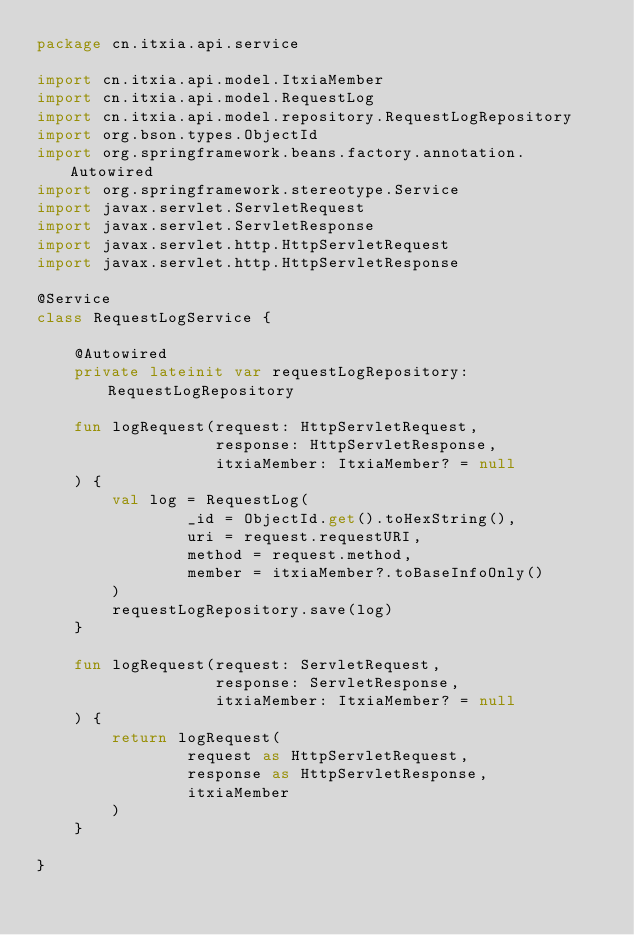Convert code to text. <code><loc_0><loc_0><loc_500><loc_500><_Kotlin_>package cn.itxia.api.service

import cn.itxia.api.model.ItxiaMember
import cn.itxia.api.model.RequestLog
import cn.itxia.api.model.repository.RequestLogRepository
import org.bson.types.ObjectId
import org.springframework.beans.factory.annotation.Autowired
import org.springframework.stereotype.Service
import javax.servlet.ServletRequest
import javax.servlet.ServletResponse
import javax.servlet.http.HttpServletRequest
import javax.servlet.http.HttpServletResponse

@Service
class RequestLogService {

    @Autowired
    private lateinit var requestLogRepository: RequestLogRepository

    fun logRequest(request: HttpServletRequest,
                   response: HttpServletResponse,
                   itxiaMember: ItxiaMember? = null
    ) {
        val log = RequestLog(
                _id = ObjectId.get().toHexString(),
                uri = request.requestURI,
                method = request.method,
                member = itxiaMember?.toBaseInfoOnly()
        )
        requestLogRepository.save(log)
    }

    fun logRequest(request: ServletRequest,
                   response: ServletResponse,
                   itxiaMember: ItxiaMember? = null
    ) {
        return logRequest(
                request as HttpServletRequest,
                response as HttpServletResponse,
                itxiaMember
        )
    }

}</code> 